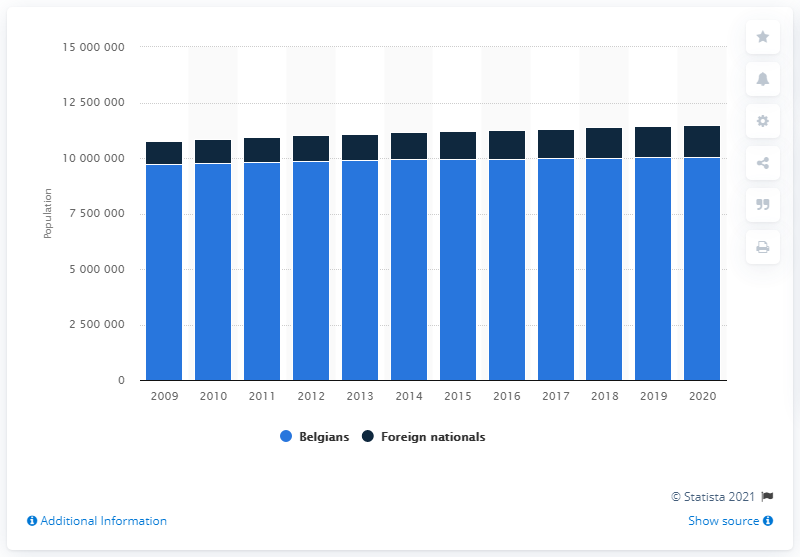Draw attention to some important aspects in this diagram. In 2020, approximately 139,1425 people living in Belgium were foreign nationals. 